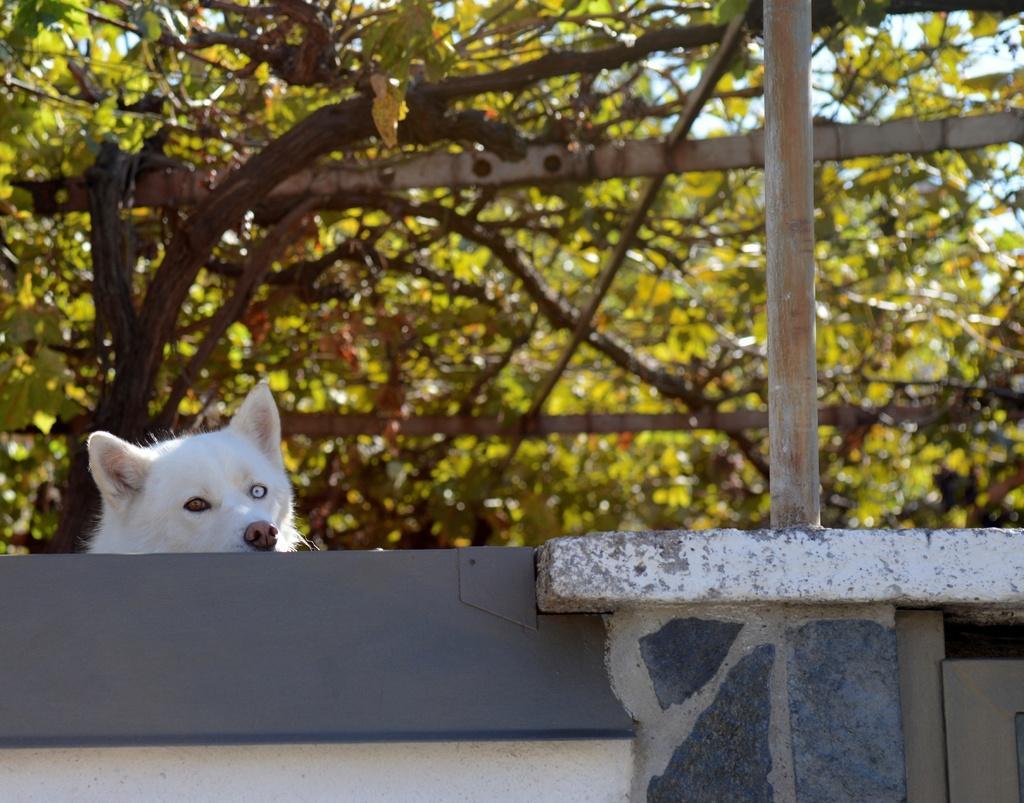Describe this image in one or two sentences. In this image I can see an animal which is in white color. I can see the pole. In the background I can see many trees and the sky. 